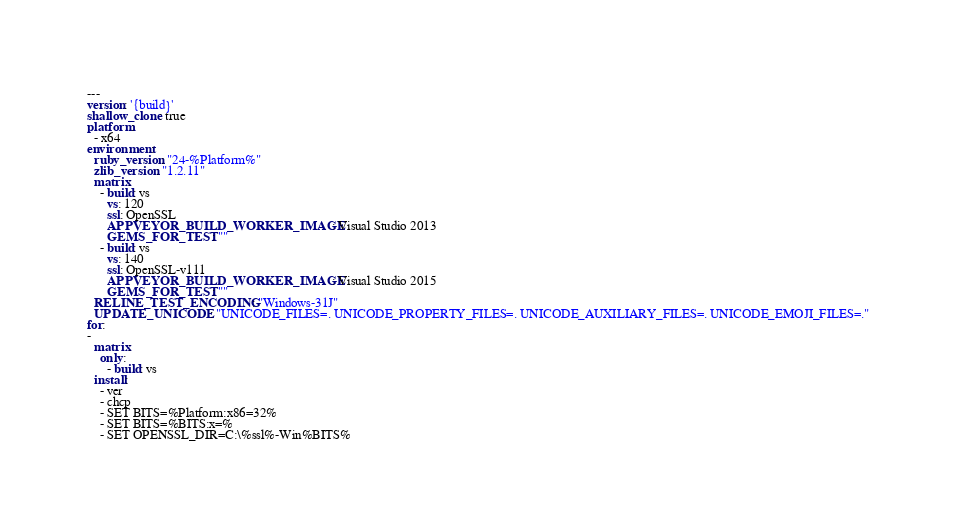Convert code to text. <code><loc_0><loc_0><loc_500><loc_500><_YAML_>---
version: '{build}'
shallow_clone: true
platform:
  - x64
environment:
  ruby_version: "24-%Platform%"
  zlib_version: "1.2.11"
  matrix:
    - build: vs
      vs: 120
      ssl: OpenSSL
      APPVEYOR_BUILD_WORKER_IMAGE: Visual Studio 2013
      GEMS_FOR_TEST: ""
    - build: vs
      vs: 140
      ssl: OpenSSL-v111
      APPVEYOR_BUILD_WORKER_IMAGE: Visual Studio 2015
      GEMS_FOR_TEST: ""
  RELINE_TEST_ENCODING: "Windows-31J"
  UPDATE_UNICODE: "UNICODE_FILES=. UNICODE_PROPERTY_FILES=. UNICODE_AUXILIARY_FILES=. UNICODE_EMOJI_FILES=."
for:
-
  matrix:
    only:
      - build: vs
  install:
    - ver
    - chcp
    - SET BITS=%Platform:x86=32%
    - SET BITS=%BITS:x=%
    - SET OPENSSL_DIR=C:\%ssl%-Win%BITS%</code> 